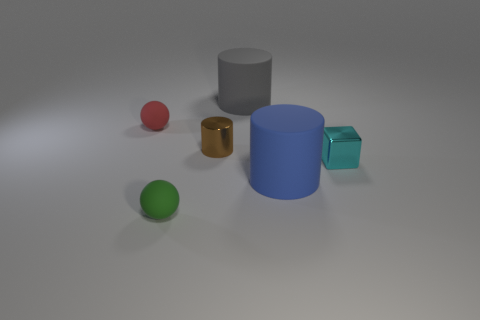Add 3 yellow metal objects. How many objects exist? 9 Subtract all spheres. How many objects are left? 4 Subtract all large matte cubes. Subtract all brown things. How many objects are left? 5 Add 6 tiny brown cylinders. How many tiny brown cylinders are left? 7 Add 5 brown metallic objects. How many brown metallic objects exist? 6 Subtract 1 gray cylinders. How many objects are left? 5 